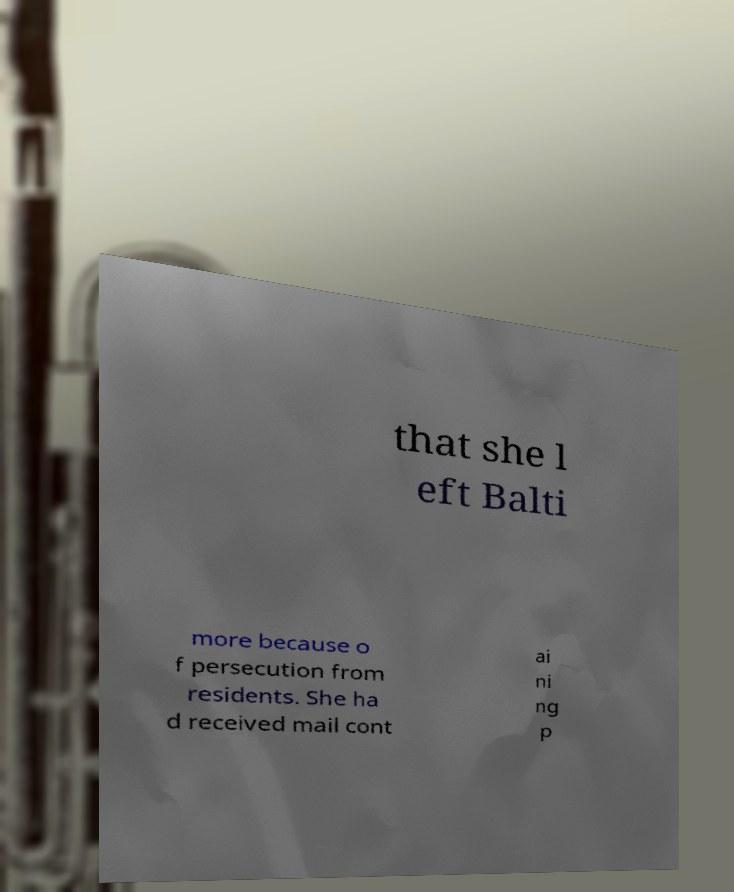Please identify and transcribe the text found in this image. that she l eft Balti more because o f persecution from residents. She ha d received mail cont ai ni ng p 